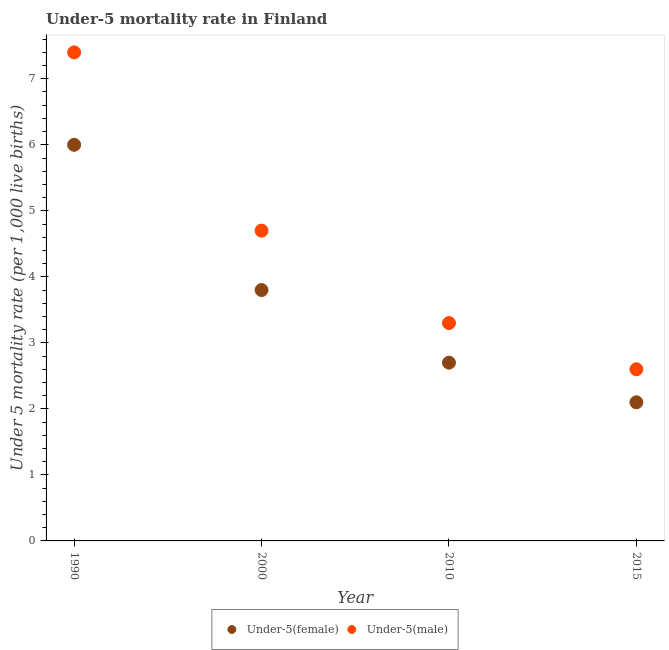How many different coloured dotlines are there?
Your response must be concise. 2. Is the number of dotlines equal to the number of legend labels?
Provide a short and direct response. Yes. What is the under-5 male mortality rate in 2000?
Make the answer very short. 4.7. Across all years, what is the maximum under-5 male mortality rate?
Ensure brevity in your answer.  7.4. In which year was the under-5 male mortality rate maximum?
Your answer should be very brief. 1990. In which year was the under-5 female mortality rate minimum?
Your answer should be very brief. 2015. What is the total under-5 male mortality rate in the graph?
Your answer should be compact. 18. What is the difference between the under-5 male mortality rate in 1990 and that in 2010?
Your answer should be compact. 4.1. What is the difference between the under-5 female mortality rate in 2010 and the under-5 male mortality rate in 2015?
Your answer should be very brief. 0.1. What is the average under-5 male mortality rate per year?
Ensure brevity in your answer.  4.5. In the year 2000, what is the difference between the under-5 female mortality rate and under-5 male mortality rate?
Offer a terse response. -0.9. In how many years, is the under-5 male mortality rate greater than 1.4?
Make the answer very short. 4. What is the ratio of the under-5 male mortality rate in 2000 to that in 2015?
Give a very brief answer. 1.81. Is the under-5 female mortality rate in 2010 less than that in 2015?
Your response must be concise. No. Is the difference between the under-5 female mortality rate in 1990 and 2000 greater than the difference between the under-5 male mortality rate in 1990 and 2000?
Keep it short and to the point. No. What is the difference between the highest and the lowest under-5 male mortality rate?
Give a very brief answer. 4.8. Is the under-5 male mortality rate strictly less than the under-5 female mortality rate over the years?
Give a very brief answer. No. How many dotlines are there?
Your response must be concise. 2. Does the graph contain any zero values?
Your answer should be compact. No. How many legend labels are there?
Ensure brevity in your answer.  2. What is the title of the graph?
Provide a short and direct response. Under-5 mortality rate in Finland. What is the label or title of the Y-axis?
Keep it short and to the point. Under 5 mortality rate (per 1,0 live births). What is the Under 5 mortality rate (per 1,000 live births) of Under-5(male) in 1990?
Give a very brief answer. 7.4. What is the Under 5 mortality rate (per 1,000 live births) of Under-5(female) in 2010?
Your answer should be compact. 2.7. What is the Under 5 mortality rate (per 1,000 live births) in Under-5(female) in 2015?
Give a very brief answer. 2.1. What is the Under 5 mortality rate (per 1,000 live births) of Under-5(male) in 2015?
Offer a terse response. 2.6. Across all years, what is the maximum Under 5 mortality rate (per 1,000 live births) in Under-5(female)?
Give a very brief answer. 6. Across all years, what is the minimum Under 5 mortality rate (per 1,000 live births) in Under-5(male)?
Provide a short and direct response. 2.6. What is the total Under 5 mortality rate (per 1,000 live births) in Under-5(female) in the graph?
Offer a very short reply. 14.6. What is the difference between the Under 5 mortality rate (per 1,000 live births) of Under-5(female) in 1990 and that in 2000?
Ensure brevity in your answer.  2.2. What is the difference between the Under 5 mortality rate (per 1,000 live births) in Under-5(male) in 1990 and that in 2000?
Your answer should be compact. 2.7. What is the difference between the Under 5 mortality rate (per 1,000 live births) of Under-5(female) in 1990 and that in 2010?
Provide a short and direct response. 3.3. What is the difference between the Under 5 mortality rate (per 1,000 live births) of Under-5(male) in 1990 and that in 2015?
Offer a very short reply. 4.8. What is the difference between the Under 5 mortality rate (per 1,000 live births) in Under-5(female) in 2000 and that in 2010?
Provide a succinct answer. 1.1. What is the difference between the Under 5 mortality rate (per 1,000 live births) in Under-5(male) in 2000 and that in 2010?
Your response must be concise. 1.4. What is the difference between the Under 5 mortality rate (per 1,000 live births) in Under-5(female) in 2010 and that in 2015?
Give a very brief answer. 0.6. What is the difference between the Under 5 mortality rate (per 1,000 live births) of Under-5(male) in 2010 and that in 2015?
Your answer should be very brief. 0.7. What is the difference between the Under 5 mortality rate (per 1,000 live births) in Under-5(female) in 1990 and the Under 5 mortality rate (per 1,000 live births) in Under-5(male) in 2000?
Offer a terse response. 1.3. What is the difference between the Under 5 mortality rate (per 1,000 live births) of Under-5(female) in 1990 and the Under 5 mortality rate (per 1,000 live births) of Under-5(male) in 2015?
Provide a succinct answer. 3.4. What is the difference between the Under 5 mortality rate (per 1,000 live births) in Under-5(female) in 2000 and the Under 5 mortality rate (per 1,000 live births) in Under-5(male) in 2015?
Keep it short and to the point. 1.2. What is the difference between the Under 5 mortality rate (per 1,000 live births) of Under-5(female) in 2010 and the Under 5 mortality rate (per 1,000 live births) of Under-5(male) in 2015?
Ensure brevity in your answer.  0.1. What is the average Under 5 mortality rate (per 1,000 live births) of Under-5(female) per year?
Offer a very short reply. 3.65. In the year 1990, what is the difference between the Under 5 mortality rate (per 1,000 live births) of Under-5(female) and Under 5 mortality rate (per 1,000 live births) of Under-5(male)?
Offer a very short reply. -1.4. In the year 2000, what is the difference between the Under 5 mortality rate (per 1,000 live births) in Under-5(female) and Under 5 mortality rate (per 1,000 live births) in Under-5(male)?
Make the answer very short. -0.9. What is the ratio of the Under 5 mortality rate (per 1,000 live births) in Under-5(female) in 1990 to that in 2000?
Make the answer very short. 1.58. What is the ratio of the Under 5 mortality rate (per 1,000 live births) in Under-5(male) in 1990 to that in 2000?
Offer a very short reply. 1.57. What is the ratio of the Under 5 mortality rate (per 1,000 live births) of Under-5(female) in 1990 to that in 2010?
Provide a short and direct response. 2.22. What is the ratio of the Under 5 mortality rate (per 1,000 live births) of Under-5(male) in 1990 to that in 2010?
Give a very brief answer. 2.24. What is the ratio of the Under 5 mortality rate (per 1,000 live births) in Under-5(female) in 1990 to that in 2015?
Give a very brief answer. 2.86. What is the ratio of the Under 5 mortality rate (per 1,000 live births) of Under-5(male) in 1990 to that in 2015?
Ensure brevity in your answer.  2.85. What is the ratio of the Under 5 mortality rate (per 1,000 live births) of Under-5(female) in 2000 to that in 2010?
Provide a succinct answer. 1.41. What is the ratio of the Under 5 mortality rate (per 1,000 live births) in Under-5(male) in 2000 to that in 2010?
Offer a terse response. 1.42. What is the ratio of the Under 5 mortality rate (per 1,000 live births) of Under-5(female) in 2000 to that in 2015?
Ensure brevity in your answer.  1.81. What is the ratio of the Under 5 mortality rate (per 1,000 live births) of Under-5(male) in 2000 to that in 2015?
Your response must be concise. 1.81. What is the ratio of the Under 5 mortality rate (per 1,000 live births) of Under-5(female) in 2010 to that in 2015?
Your response must be concise. 1.29. What is the ratio of the Under 5 mortality rate (per 1,000 live births) of Under-5(male) in 2010 to that in 2015?
Offer a terse response. 1.27. What is the difference between the highest and the lowest Under 5 mortality rate (per 1,000 live births) of Under-5(male)?
Make the answer very short. 4.8. 